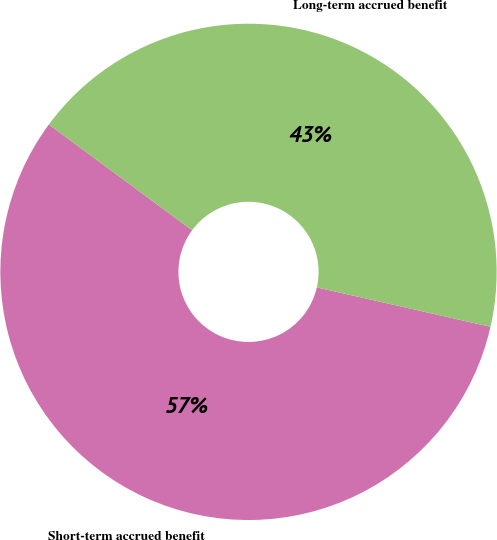<chart> <loc_0><loc_0><loc_500><loc_500><pie_chart><fcel>Short-term accrued benefit<fcel>Long-term accrued benefit<nl><fcel>56.57%<fcel>43.43%<nl></chart> 